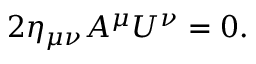<formula> <loc_0><loc_0><loc_500><loc_500>2 \eta _ { \mu \nu } A ^ { \mu } U ^ { \nu } = 0 .</formula> 